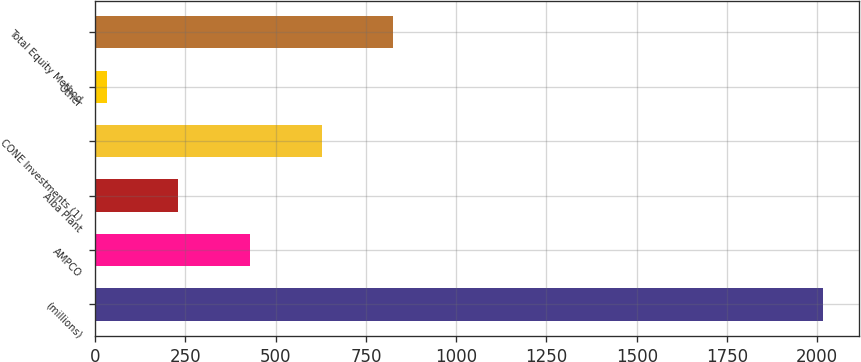<chart> <loc_0><loc_0><loc_500><loc_500><bar_chart><fcel>(millions)<fcel>AMPCO<fcel>Alba Plant<fcel>CONE Investments (1)<fcel>Other<fcel>Total Equity Method<nl><fcel>2015<fcel>428.6<fcel>230.3<fcel>626.9<fcel>32<fcel>825.2<nl></chart> 